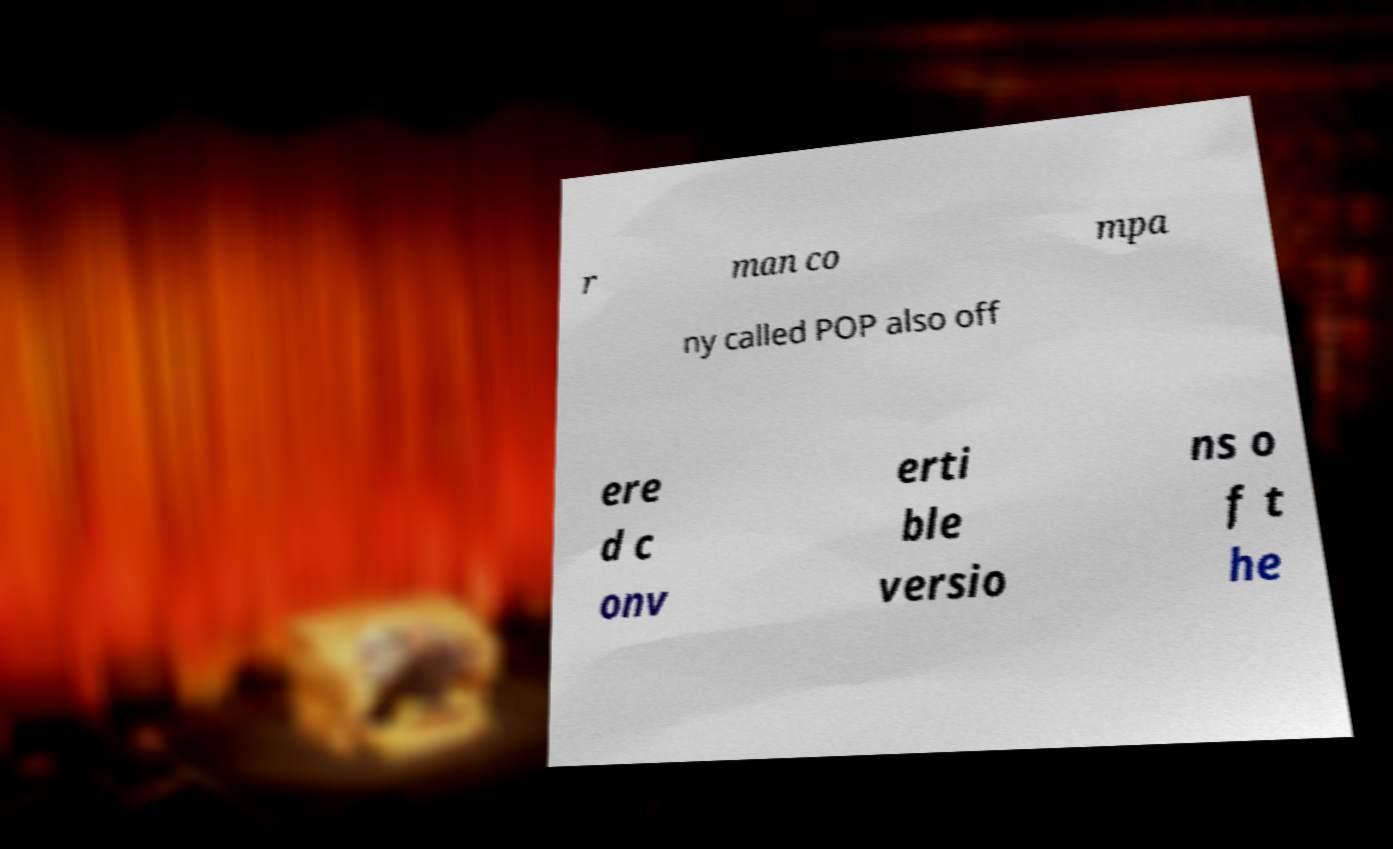Please identify and transcribe the text found in this image. r man co mpa ny called POP also off ere d c onv erti ble versio ns o f t he 